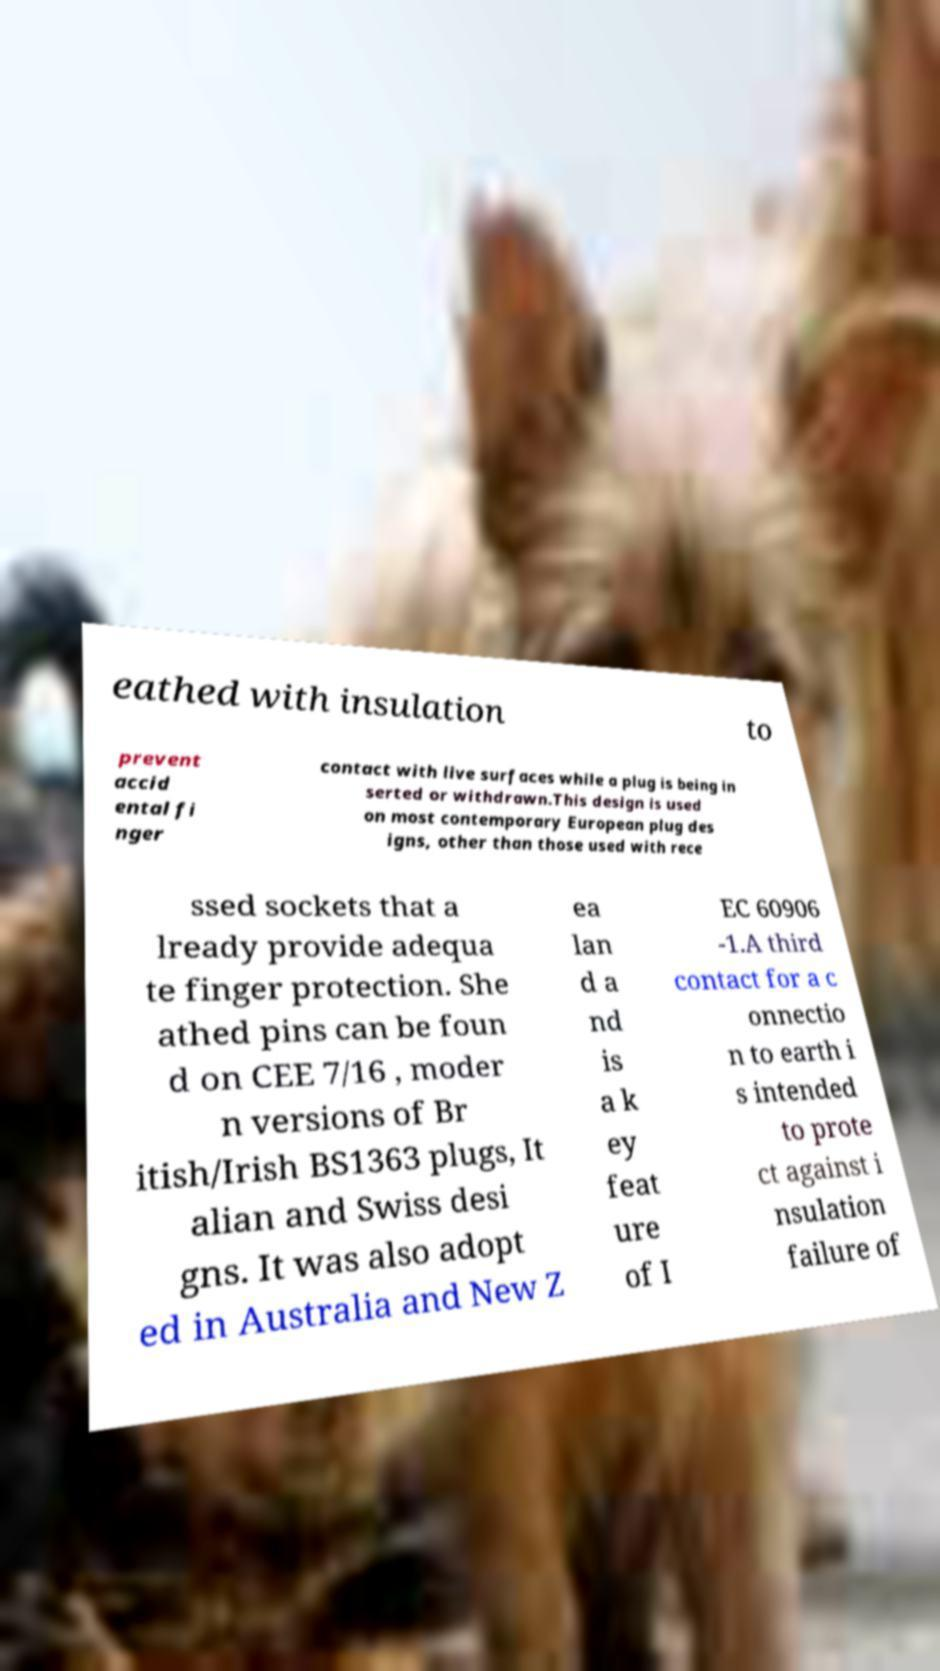Could you assist in decoding the text presented in this image and type it out clearly? eathed with insulation to prevent accid ental fi nger contact with live surfaces while a plug is being in serted or withdrawn.This design is used on most contemporary European plug des igns, other than those used with rece ssed sockets that a lready provide adequa te finger protection. She athed pins can be foun d on CEE 7/16 , moder n versions of Br itish/Irish BS1363 plugs, It alian and Swiss desi gns. It was also adopt ed in Australia and New Z ea lan d a nd is a k ey feat ure of I EC 60906 -1.A third contact for a c onnectio n to earth i s intended to prote ct against i nsulation failure of 